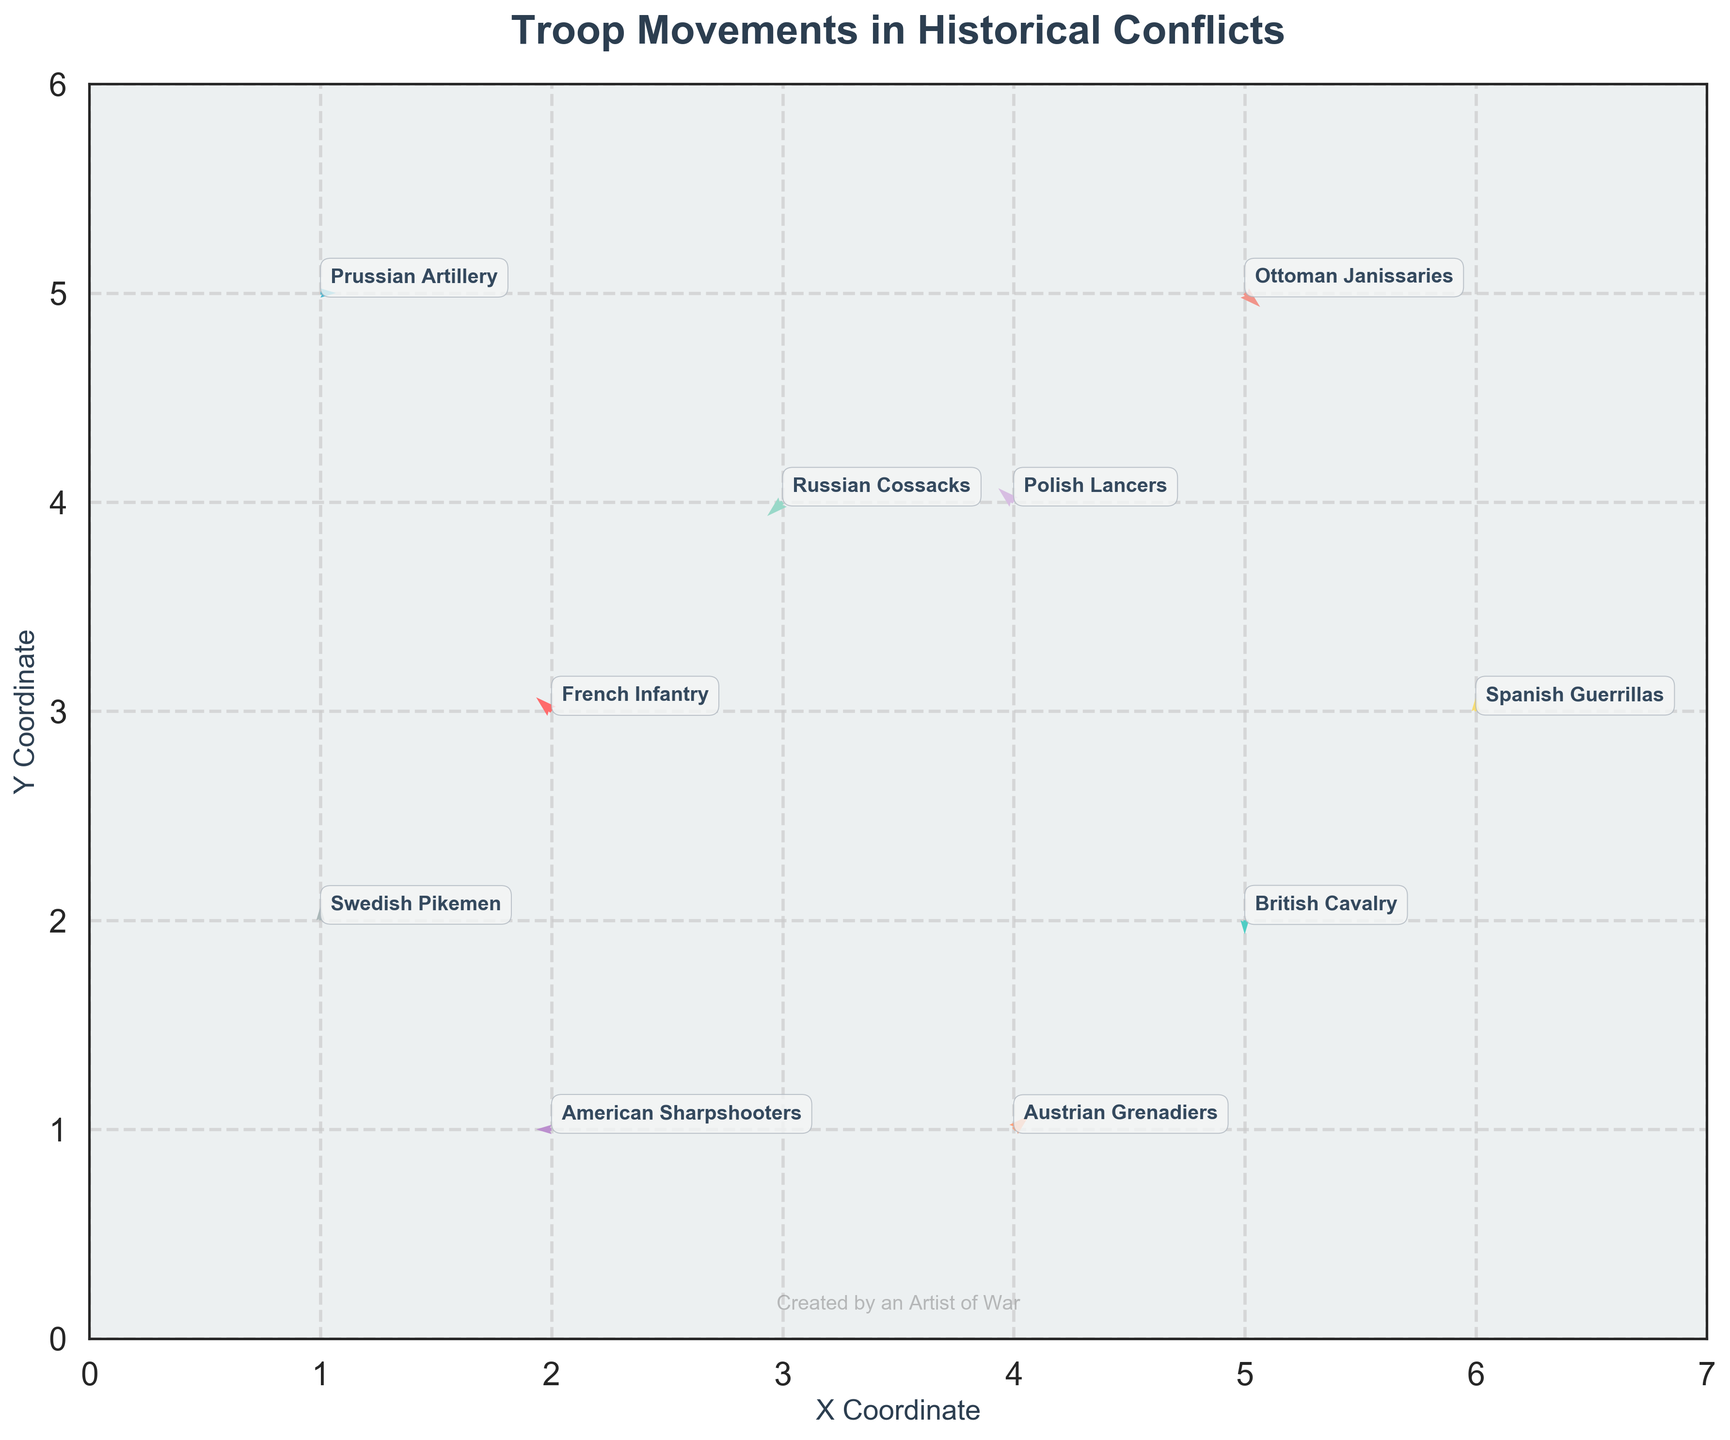What is the title of the plot? The title of the plot is usually displayed at the top of the figure in a larger and bolder font.
Answer: Troop Movements in Historical Conflicts What are the labels on the X and Y axes? The axis labels are typically shown alongside the respective axes, with the X-axis label at the bottom and the Y-axis label on the left.
Answer: X Coordinate, Y Coordinate How many troop movements are represented in the plot? Each movement is depicted by an arrow, and there are 10 data points representing the movements of different troops.
Answer: 10 Which troop shows the largest vector magnitude? The magnitude of a vector can be calculated using Pythagoras' theorem as the square root of the sum of the squares of its components (u and v). The Austrian Grenadiers have the largest magnitude given by sqrt(1^2 + 1^2) = sqrt(2).
Answer: Austrian Grenadiers What direction are the British Cavalry moving in? The direction can be inferred from the u and v components of the quiver. The British Cavalry have (0, -1), indicating they move directly downwards (south).
Answer: Downwards (South) Which troop movement is represented by the longest arrow in the plot? The arrow length represents the magnitude of the vector. The Austrian Grenadiers have the longest arrow with both u and v as 1.
Answer: Austrian Grenadiers Which troops are moving horizontally? A horizontal movement corresponds to a v component of zero. The Prussian Artillery (v=0) and American Sharpshooters (v=0) have horizontal movements.
Answer: Prussian Artillery, American Sharpshooters What are the coordinates of the Russian Cossacks, and in what direction are they moving? The coordinates of Russian Cossacks are given as (3,4), and their u and v components are -1 and -1, respectively, indicating a south-west direction.
Answer: (3,4), South-West What is the cumulative horizontal (u) movement of all troops? Sum up all u components: -1 (French Infantry) + 0 (British Cavalry) + 1 (Prussian Artillery) + 1 (Austrian Grenadiers) -1 (Russian Cossacks) + 0 (Spanish Guerrillas) -1 (American Sharpshooters) + 1 (Ottoman Janissaries) + 0 (Swedish Pikemen) -1 (Polish Lancers) = -1.
Answer: -1 